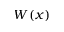Convert formula to latex. <formula><loc_0><loc_0><loc_500><loc_500>W ( x )</formula> 